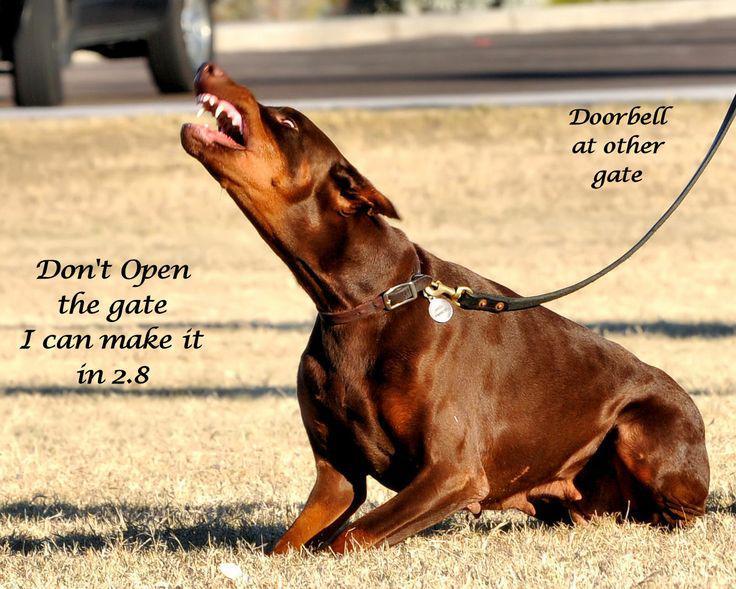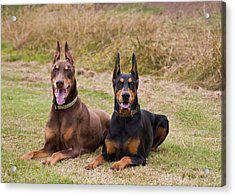The first image is the image on the left, the second image is the image on the right. For the images displayed, is the sentence "Two doberman with erect, pointy ears are facing forward and posed side-by-side in the right image." factually correct? Answer yes or no. Yes. The first image is the image on the left, the second image is the image on the right. Given the left and right images, does the statement "Two dogs are sitting in the grass in the image on the right." hold true? Answer yes or no. Yes. 